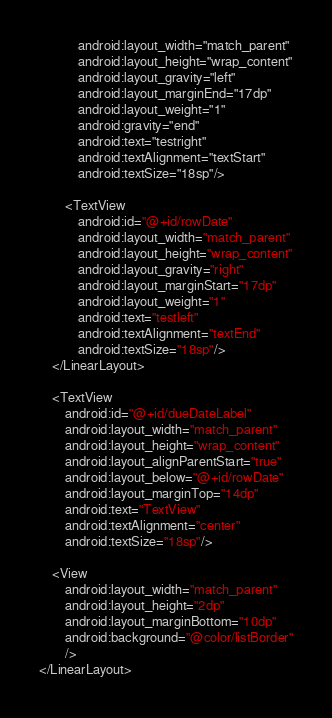<code> <loc_0><loc_0><loc_500><loc_500><_XML_>            android:layout_width="match_parent"
            android:layout_height="wrap_content"
            android:layout_gravity="left"
            android:layout_marginEnd="17dp"
            android:layout_weight="1"
            android:gravity="end"
            android:text="testright"
            android:textAlignment="textStart"
            android:textSize="18sp"/>

        <TextView
            android:id="@+id/rowDate"
            android:layout_width="match_parent"
            android:layout_height="wrap_content"
            android:layout_gravity="right"
            android:layout_marginStart="17dp"
            android:layout_weight="1"
            android:text="testleft"
            android:textAlignment="textEnd"
            android:textSize="18sp"/>
    </LinearLayout>

    <TextView
        android:id="@+id/dueDateLabel"
        android:layout_width="match_parent"
        android:layout_height="wrap_content"
        android:layout_alignParentStart="true"
        android:layout_below="@+id/rowDate"
        android:layout_marginTop="14dp"
        android:text="TextView"
        android:textAlignment="center"
        android:textSize="18sp"/>

    <View
        android:layout_width="match_parent"
        android:layout_height="2dp"
        android:layout_marginBottom="10dp"
        android:background="@color/listBorder"
        />
</LinearLayout></code> 